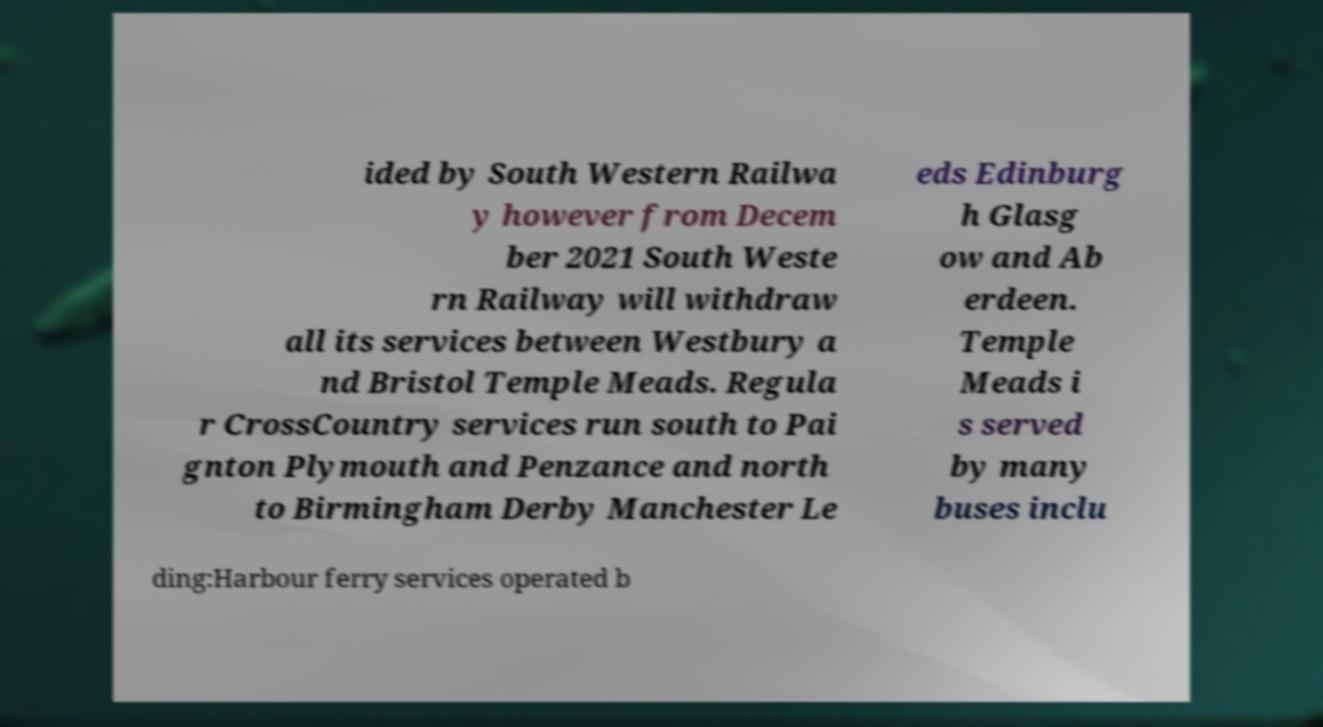Can you accurately transcribe the text from the provided image for me? ided by South Western Railwa y however from Decem ber 2021 South Weste rn Railway will withdraw all its services between Westbury a nd Bristol Temple Meads. Regula r CrossCountry services run south to Pai gnton Plymouth and Penzance and north to Birmingham Derby Manchester Le eds Edinburg h Glasg ow and Ab erdeen. Temple Meads i s served by many buses inclu ding:Harbour ferry services operated b 